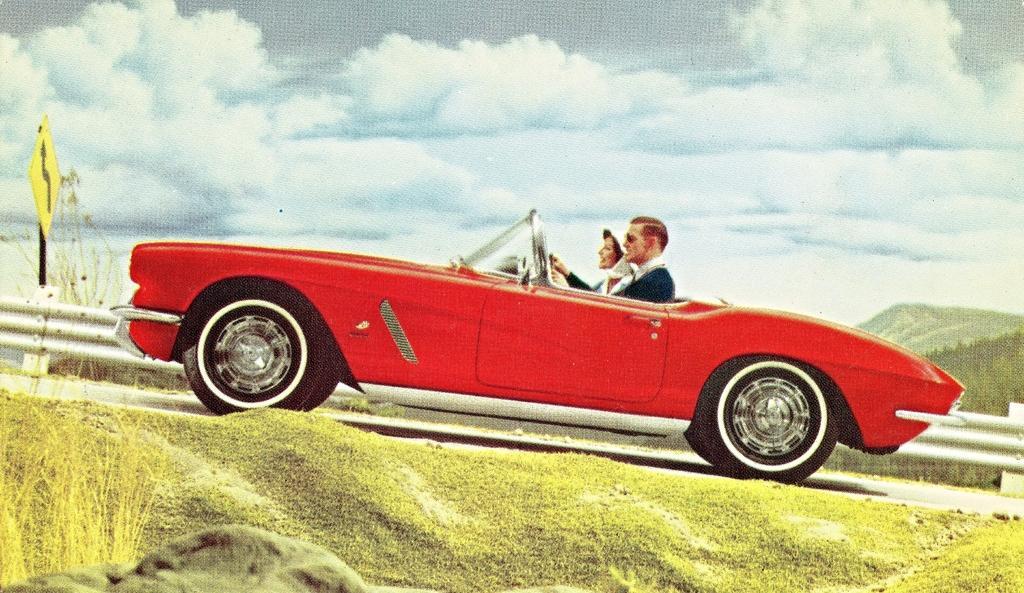Can you describe this image briefly? In the image there is a man and woman sitting inside a car going on the road, in the front there is sand and dry on the left side, in the back there is a hill on the right side and above its sky with clouds, there is a caution board beside the road. 